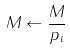Convert formula to latex. <formula><loc_0><loc_0><loc_500><loc_500>M \leftarrow { \frac { M } { p _ { i } } }</formula> 